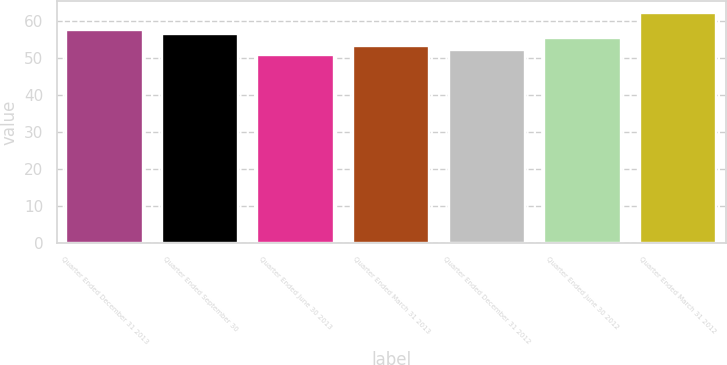Convert chart. <chart><loc_0><loc_0><loc_500><loc_500><bar_chart><fcel>Quarter Ended December 31 2013<fcel>Quarter Ended September 30<fcel>Quarter Ended June 30 2013<fcel>Quarter Ended March 31 2013<fcel>Quarter Ended December 31 2012<fcel>Quarter Ended June 30 2012<fcel>Quarter Ended March 31 2012<nl><fcel>57.59<fcel>56.46<fcel>50.81<fcel>53.07<fcel>51.94<fcel>55.33<fcel>62.13<nl></chart> 